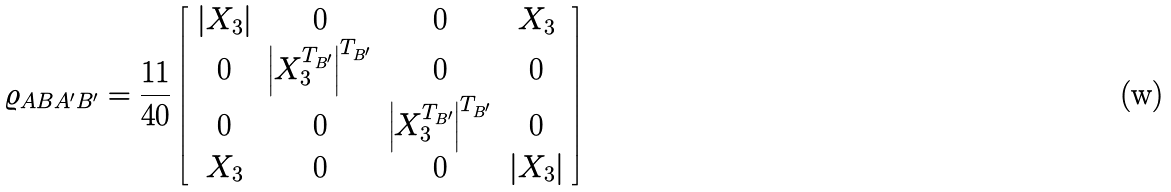<formula> <loc_0><loc_0><loc_500><loc_500>\varrho _ { A B A ^ { \prime } B ^ { \prime } } = \frac { 1 1 } { 4 0 } \left [ \begin{array} { c c c c } | X _ { 3 } | & 0 & 0 & X _ { 3 } \\ 0 & \left | X ^ { T _ { B ^ { \prime } } } _ { 3 } \right | ^ { T _ { B ^ { \prime } } } & 0 & 0 \\ 0 & 0 & \left | X ^ { T _ { B ^ { \prime } } } _ { 3 } \right | ^ { T _ { B ^ { \prime } } } & 0 \\ X _ { 3 } & 0 & 0 & | X _ { 3 } | \end{array} \right ]</formula> 